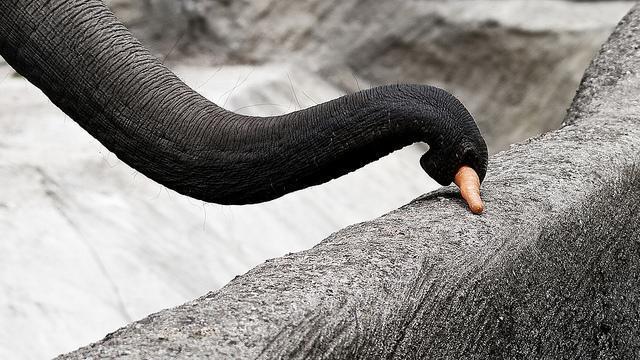How many elephants are visible?
Give a very brief answer. 1. 